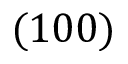<formula> <loc_0><loc_0><loc_500><loc_500>( 1 0 0 )</formula> 